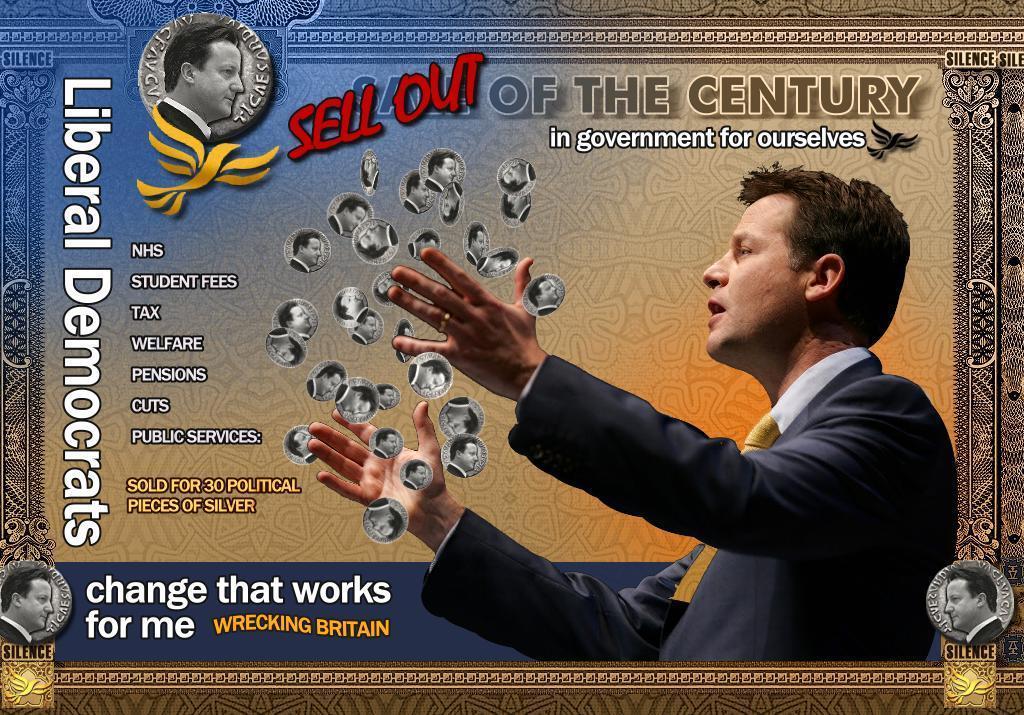Describe this image in one or two sentences. It is an edited image with borders. In this image we can see a man. We can also see the same man with different images. We can also see the text, logo and also the depiction of birds. 